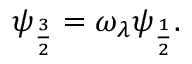<formula> <loc_0><loc_0><loc_500><loc_500>\psi _ { \frac { 3 } { 2 } } = \omega _ { \lambda } \psi _ { \frac { 1 } { 2 } } .</formula> 